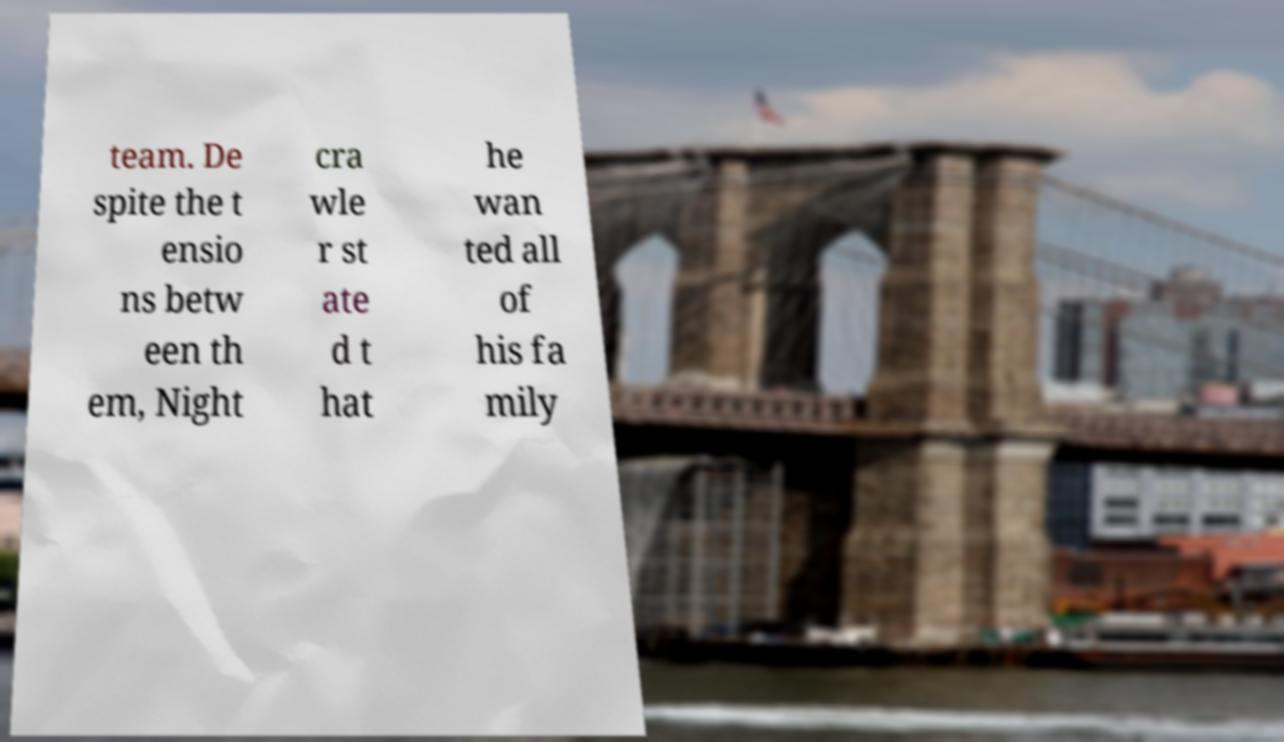Could you extract and type out the text from this image? team. De spite the t ensio ns betw een th em, Night cra wle r st ate d t hat he wan ted all of his fa mily 